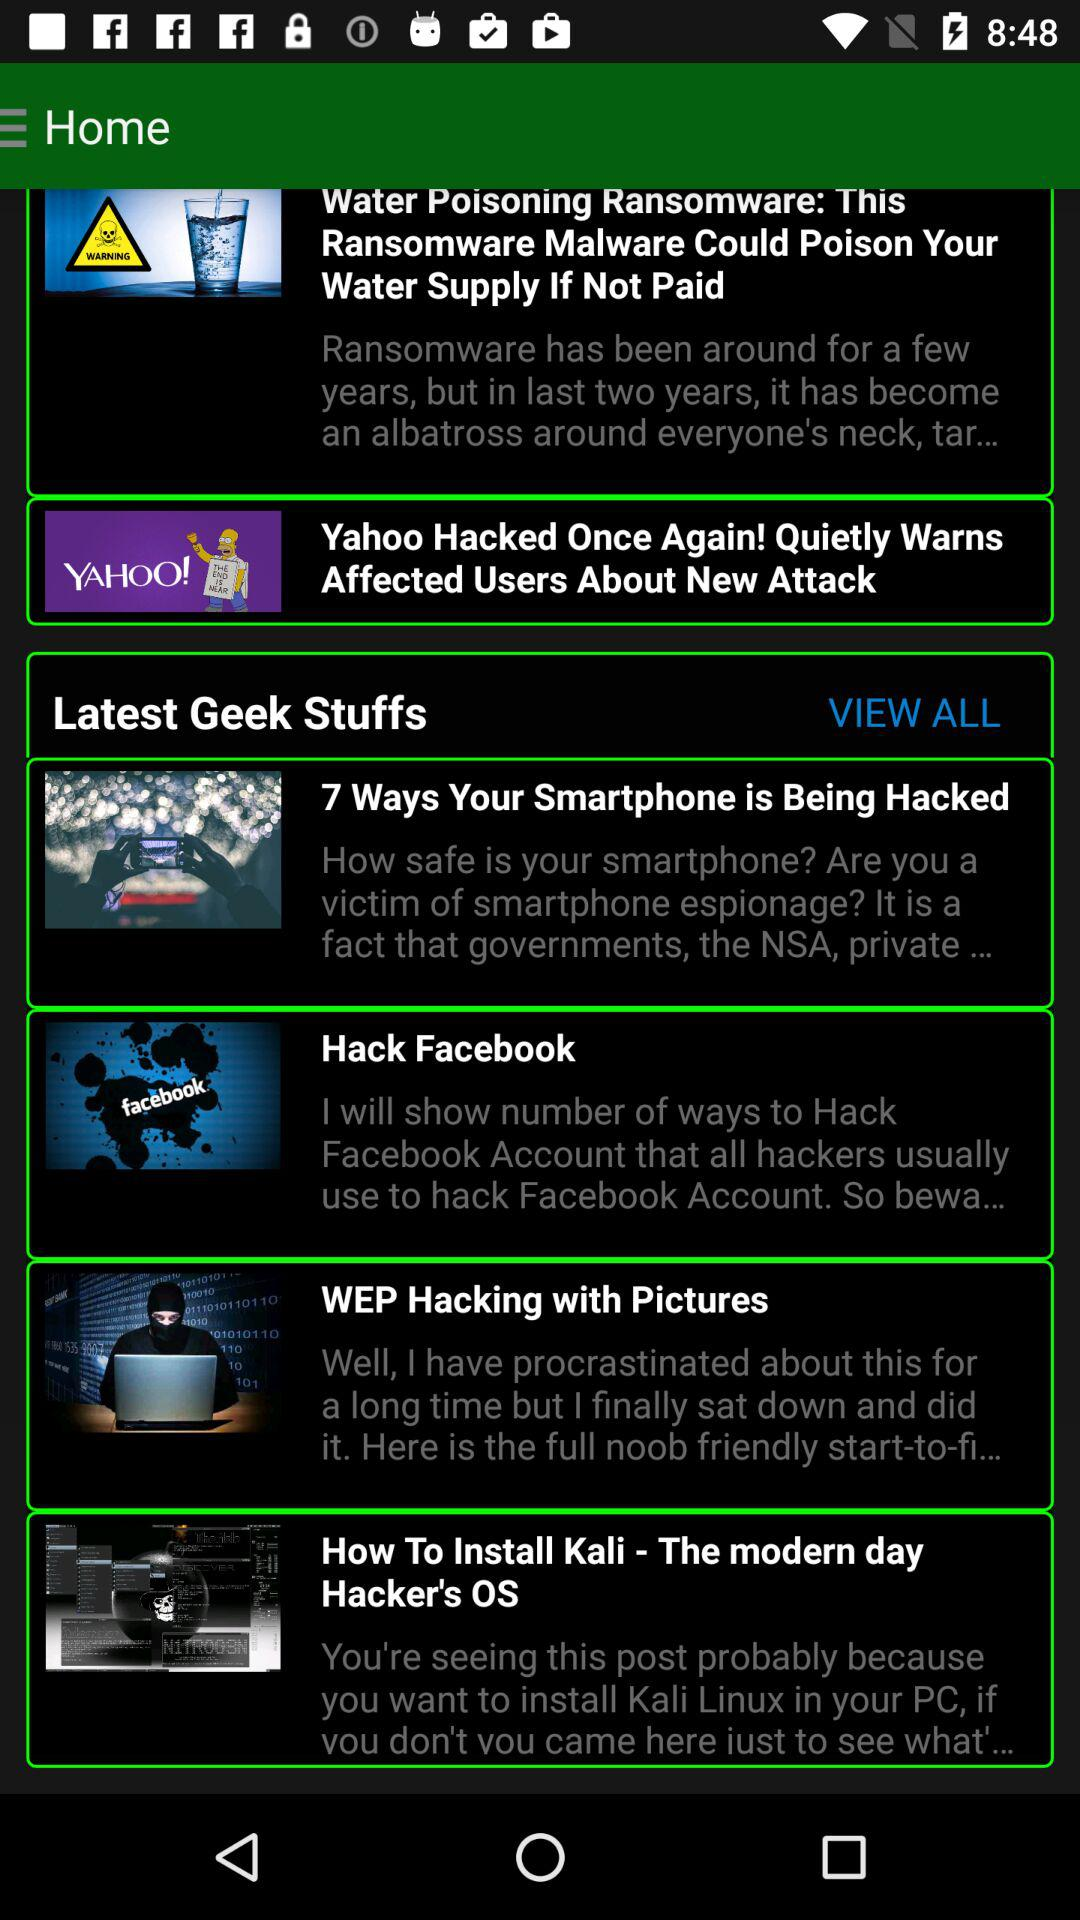In how many ways are smartphones being hacked? Smartphones are being hacked in 7 ways. 